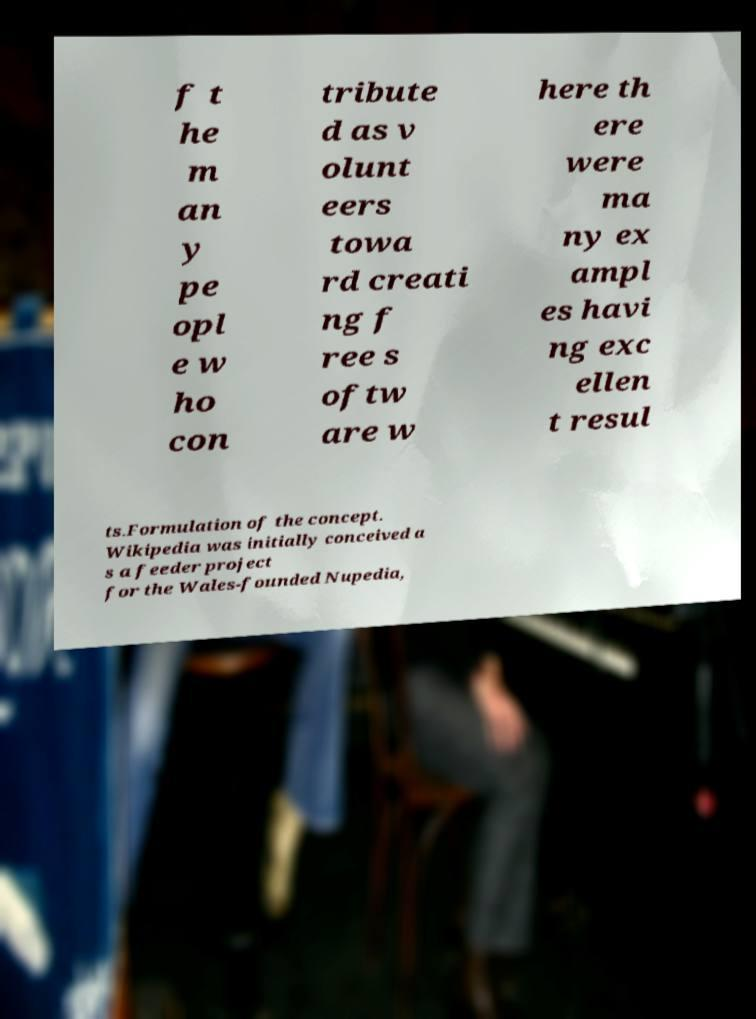I need the written content from this picture converted into text. Can you do that? f t he m an y pe opl e w ho con tribute d as v olunt eers towa rd creati ng f ree s oftw are w here th ere were ma ny ex ampl es havi ng exc ellen t resul ts.Formulation of the concept. Wikipedia was initially conceived a s a feeder project for the Wales-founded Nupedia, 